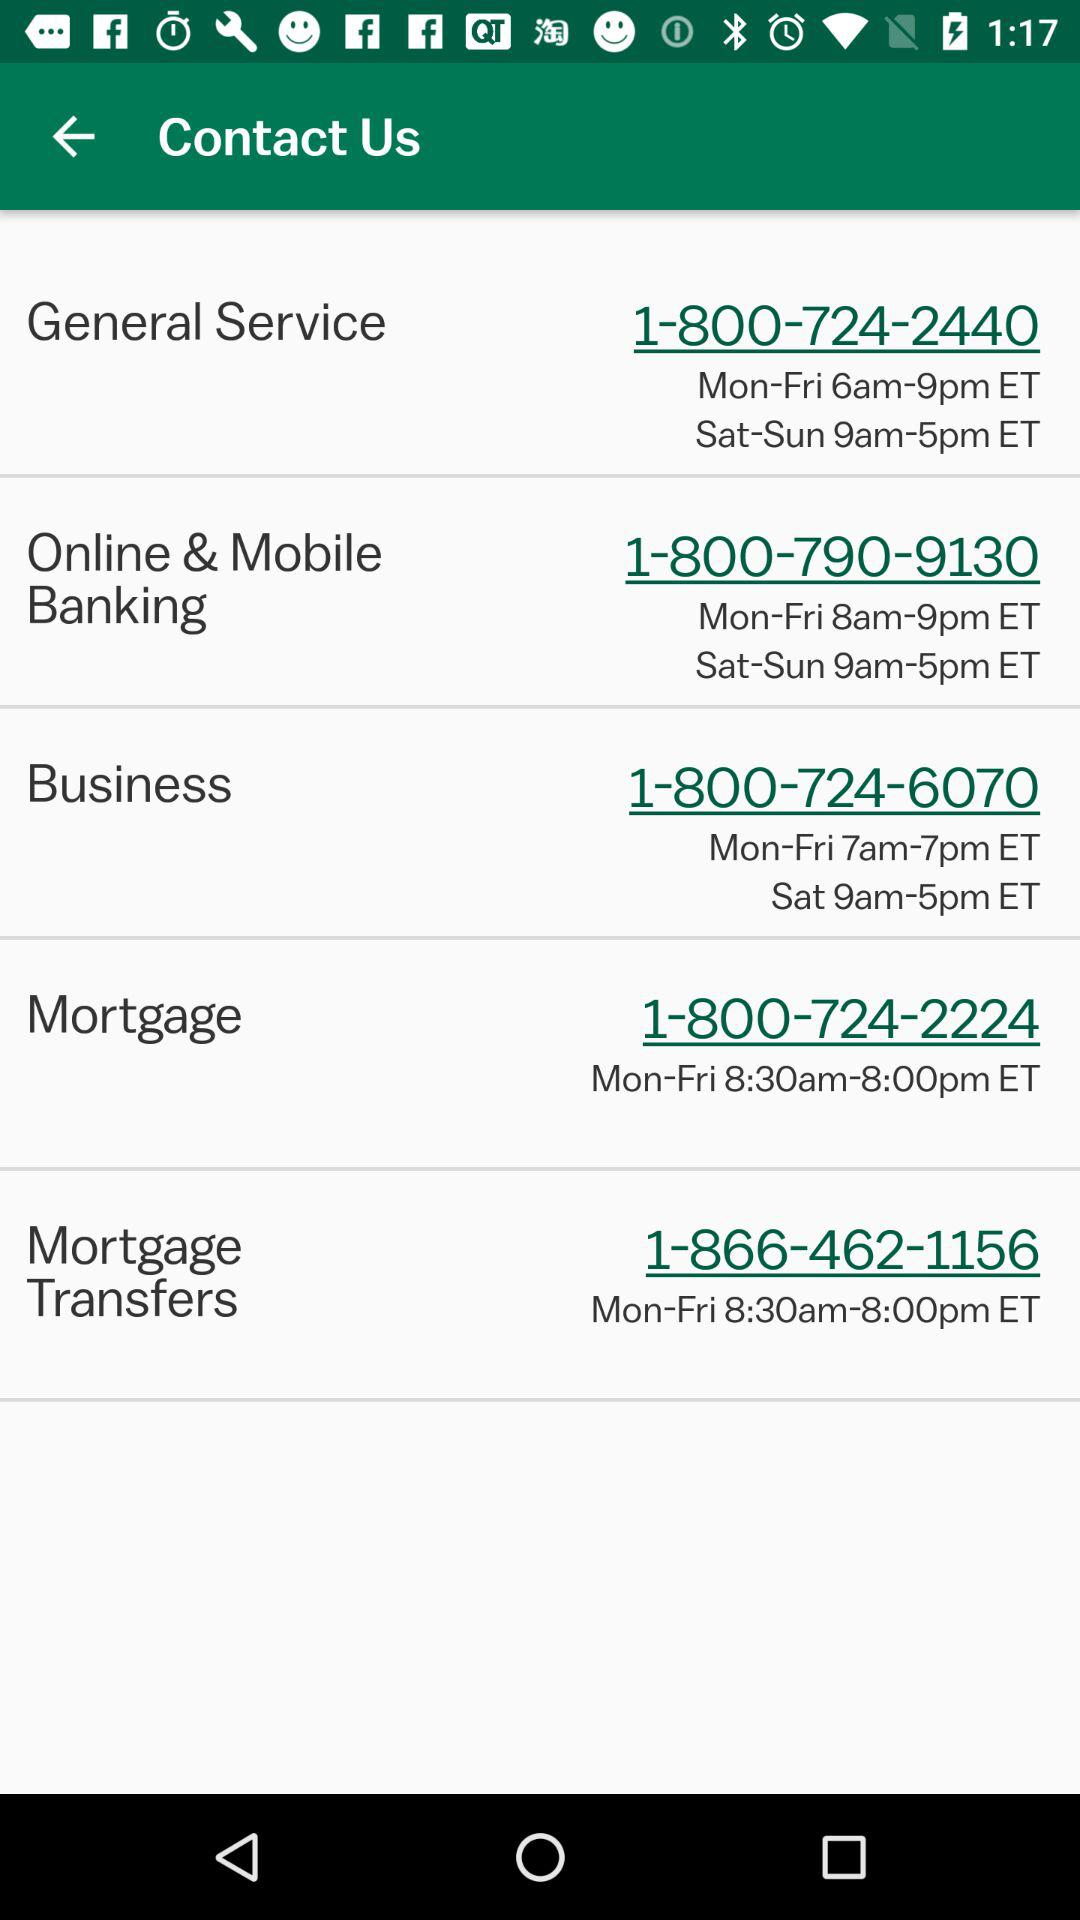What is the contact email for "General Service"?
When the provided information is insufficient, respond with <no answer>. <no answer> 